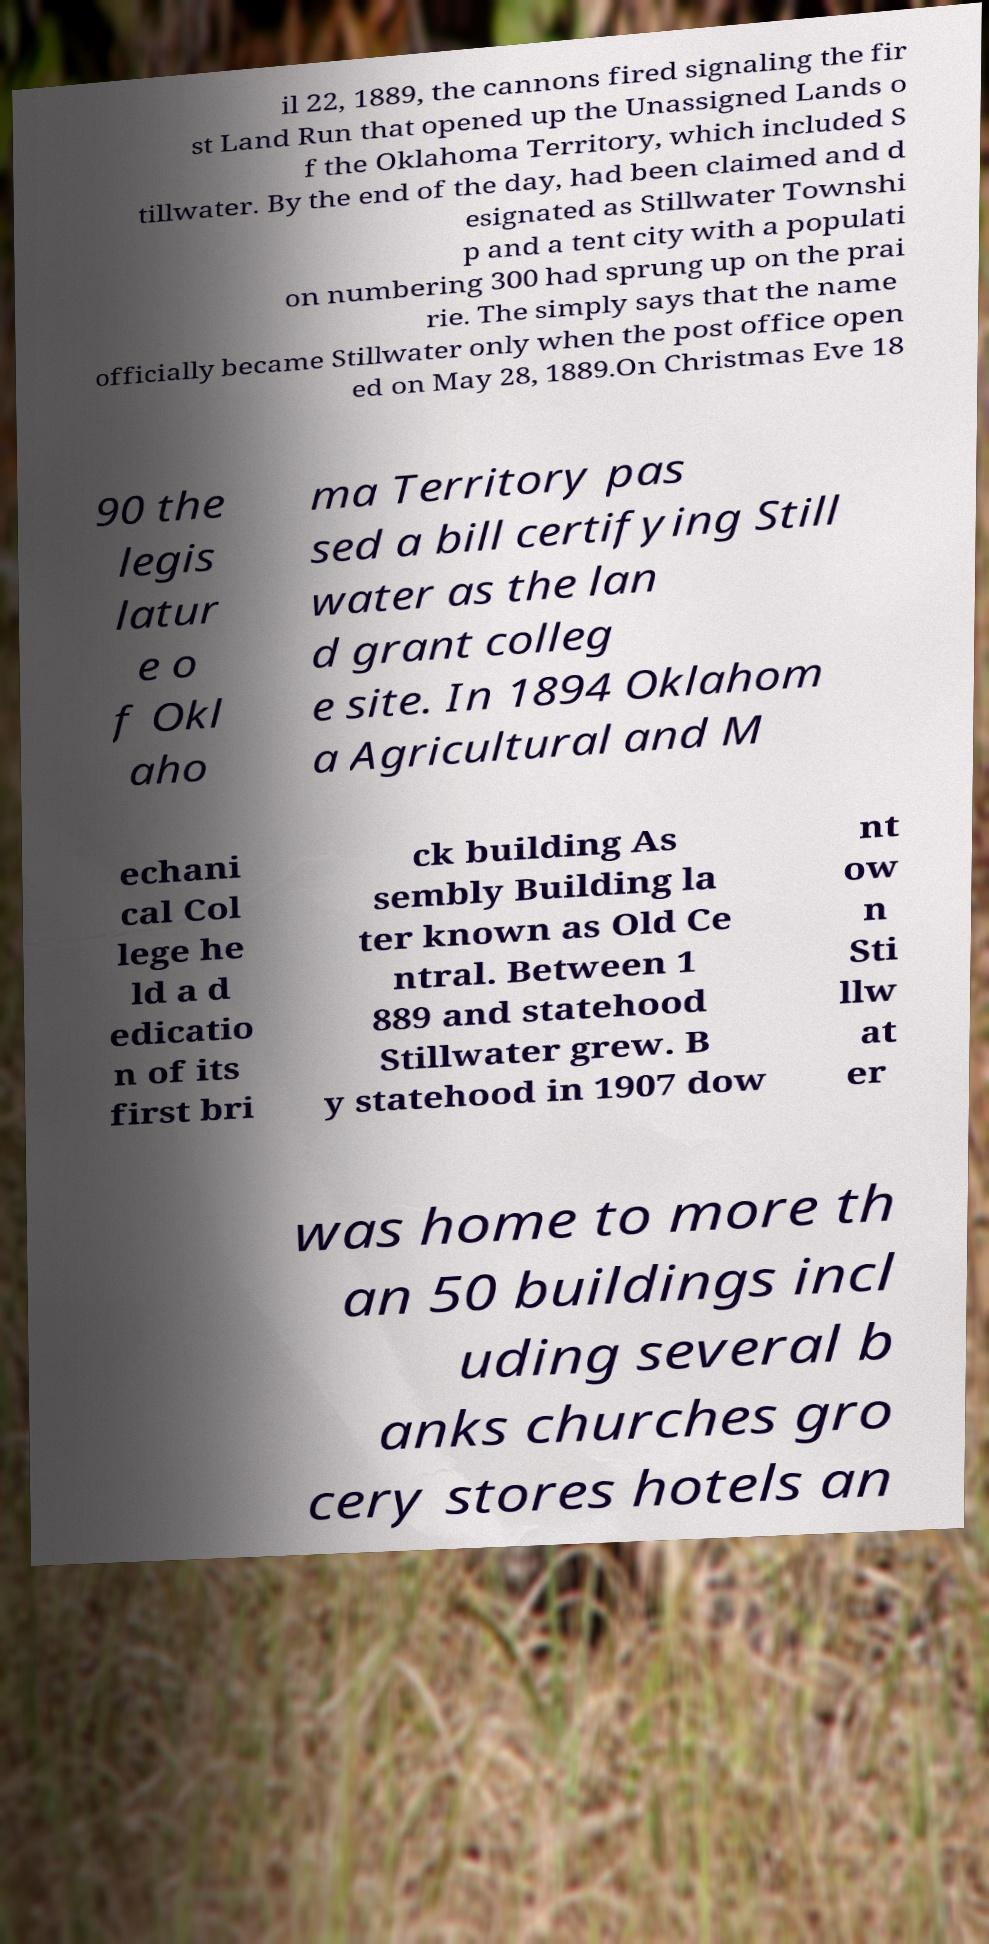Can you accurately transcribe the text from the provided image for me? il 22, 1889, the cannons fired signaling the fir st Land Run that opened up the Unassigned Lands o f the Oklahoma Territory, which included S tillwater. By the end of the day, had been claimed and d esignated as Stillwater Townshi p and a tent city with a populati on numbering 300 had sprung up on the prai rie. The simply says that the name officially became Stillwater only when the post office open ed on May 28, 1889.On Christmas Eve 18 90 the legis latur e o f Okl aho ma Territory pas sed a bill certifying Still water as the lan d grant colleg e site. In 1894 Oklahom a Agricultural and M echani cal Col lege he ld a d edicatio n of its first bri ck building As sembly Building la ter known as Old Ce ntral. Between 1 889 and statehood Stillwater grew. B y statehood in 1907 dow nt ow n Sti llw at er was home to more th an 50 buildings incl uding several b anks churches gro cery stores hotels an 